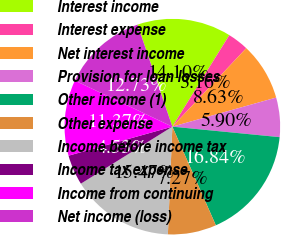<chart> <loc_0><loc_0><loc_500><loc_500><pie_chart><fcel>Interest income<fcel>Interest expense<fcel>Net interest income<fcel>Provision for loan losses<fcel>Other income (1)<fcel>Other expense<fcel>Income before income tax<fcel>Income tax expense<fcel>Income from continuing<fcel>Net income (loss)<nl><fcel>14.1%<fcel>3.16%<fcel>8.63%<fcel>5.9%<fcel>16.84%<fcel>7.27%<fcel>15.47%<fcel>4.53%<fcel>11.37%<fcel>12.73%<nl></chart> 